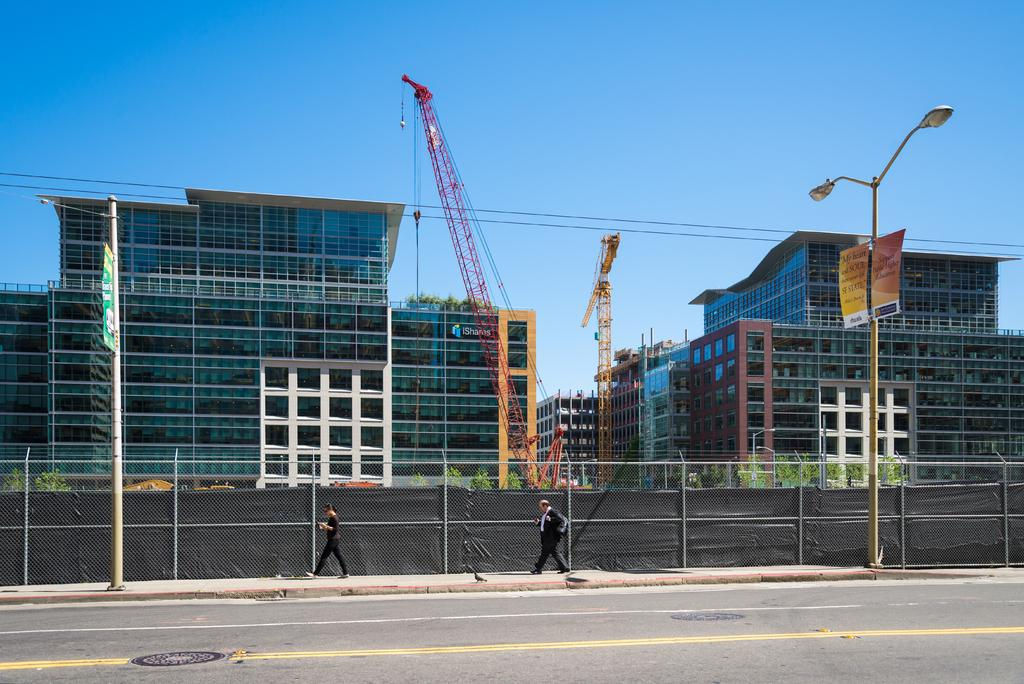What is the main feature of the image? There is a road in the image. What are the people near the road doing? There are people walking near the road. What can be seen alongside the road? There is fencing in the image. What else can be seen in the background of the image? There are constructing buildings visible in the image. What type of pin can be seen holding the weather report on the road? There is no pin or weather report present in the image; it features a road, people walking, fencing, and constructing buildings. 